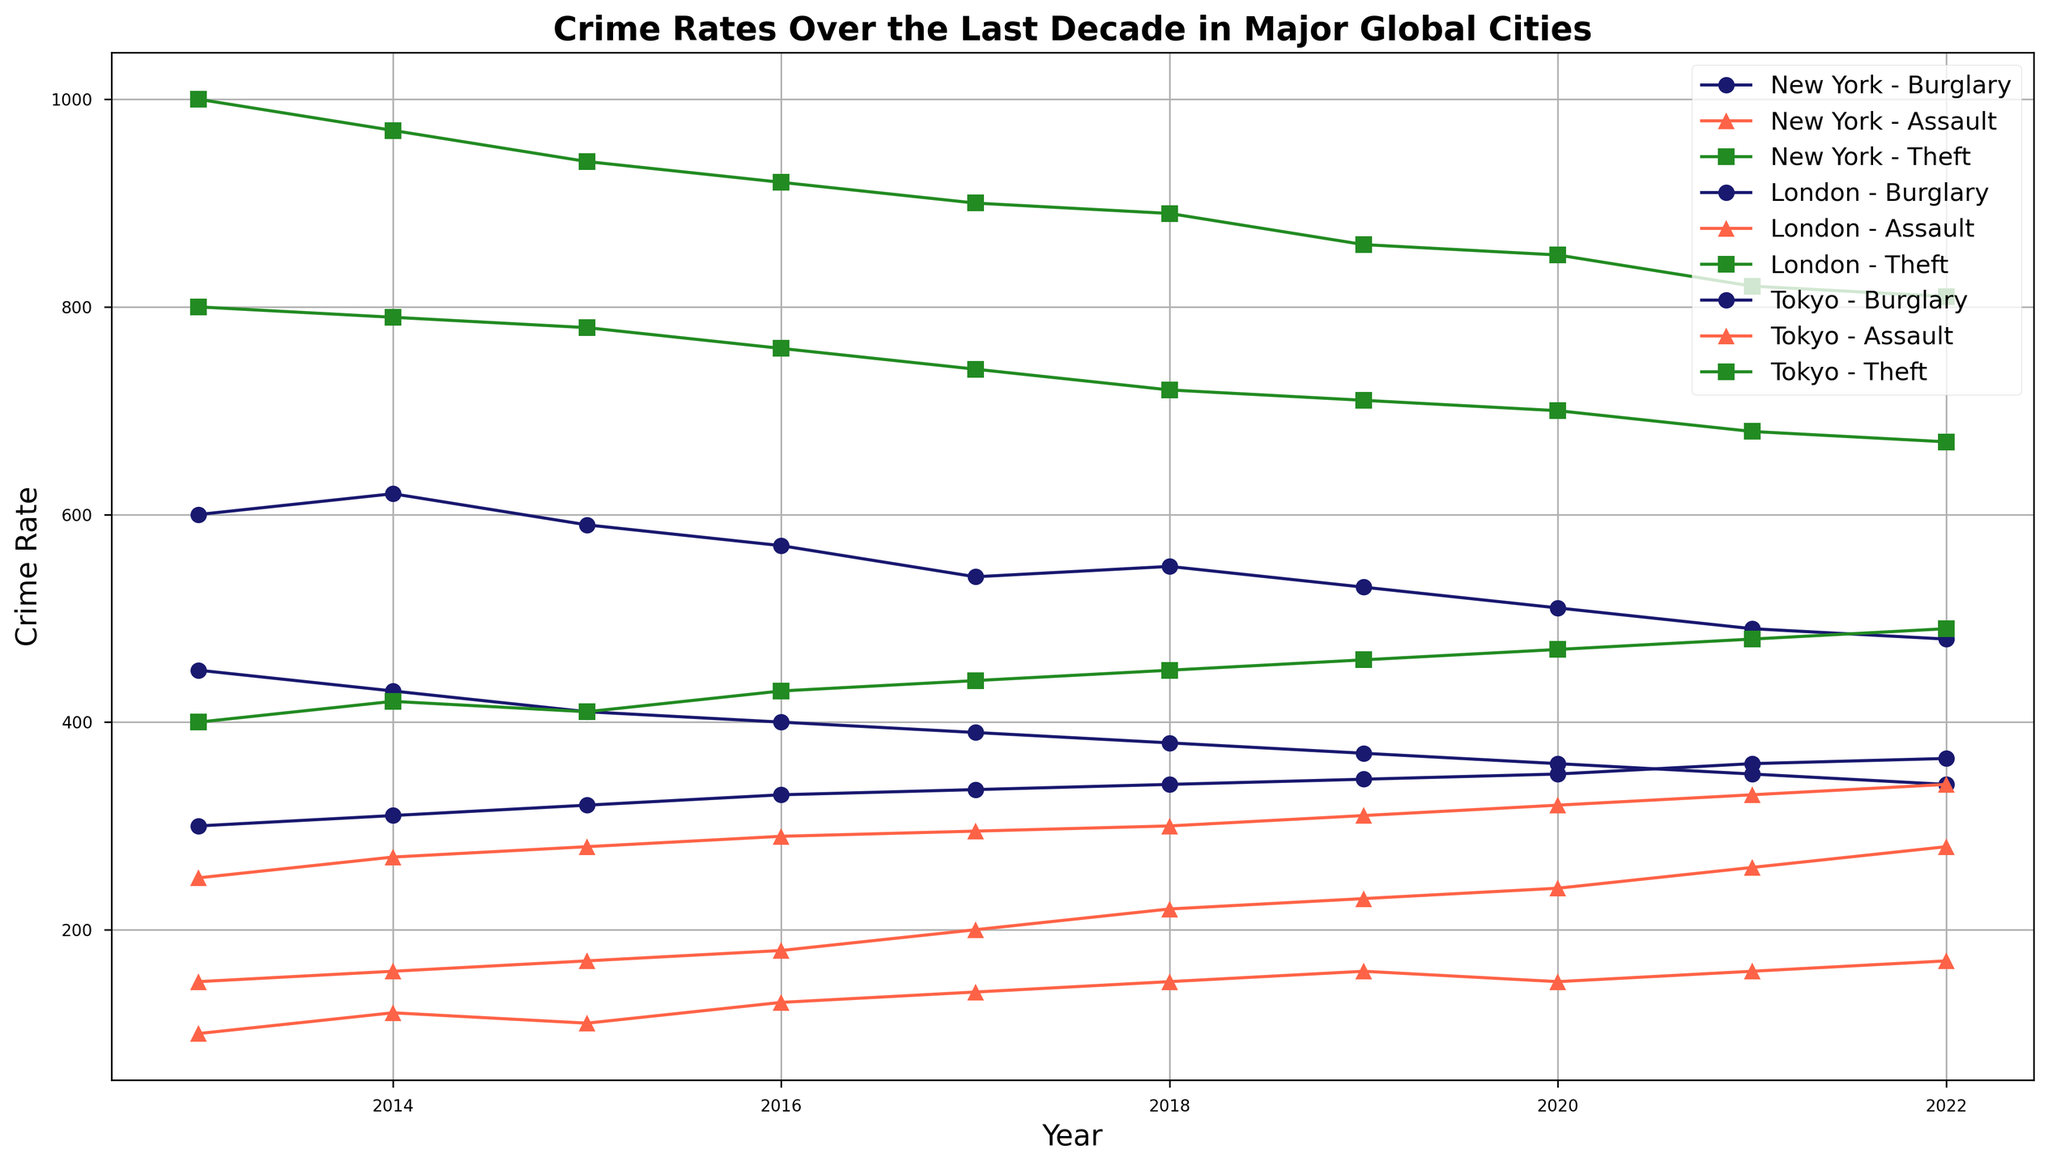What trend can be observed in the burglary rates in New York over the past decade? To observe the trend, look at the line representing the burglary rates in New York (marked as circles and colored in midnight blue). The trend shows a gradual decrease in the burglary rates from 2013 to 2022.
Answer: Gradual decrease Which city had the highest rate of theft in 2016? Compare the theft crime rates (colored in forest green) for all three cities (New York, London, Tokyo) in the year 2016. London had the highest theft rate at 920.
Answer: London Did Tokyo ever have a year where assault rates were higher than New York? Examine the assault rates (marked as triangles and colored in tomato) for both Tokyo and New York across all years. Tokyo's assault rates were consistently lower than New York's across all years.
Answer: No What is the difference in the theft crime rate between Tokyo and London in 2022? Identify the theft crime rates for Tokyo and London in 2022 from the figure. Tokyo had a rate of 490, and London had a rate of 810. The difference is 810 - 490.
Answer: 320 In which year did London see the peak burglary rate, and what was it? Look at London's burglary rates (marked as circles and colored in midnight blue) across all years. The peak burglary rate was in 2014, with a rate of 620.
Answer: 2014, 620 Compare the trends in assault crime rates across the three cities. Examine the assault crime rate lines (marked as triangles and colored in tomato) for all three cities. New York's assault rates increase over time, London's assault rates increase but slower, and Tokyo's increase slightly but more steadily.
Answer: New York increase, London slower increase, Tokyo slight increase What is the average burglary rate in Tokyo from 2013 to 2022? Take the burglary rates for Tokyo from 2013 to 2022 and calculate the average. The rates are 300, 310, 320, 330, 335, 340, 345, 350, 360, 365. The sum is 3355, and the average is 3355/10.
Answer: 335.5 Which type of crime saw the most significant decrease in New York over the decade? Compare the trends of burglary, assault, and theft crime rates in New York over the decade. Burglary rates saw a significant decrease from 450 to 340.
Answer: Burglary How did the theft rates in New York change between 2015 and 2020? Compare the theft rates in New York in 2015 and 2020. In 2015, the rate was 780, and in 2020, it was 700. The change is a decrease of 80.
Answer: Decreased by 80 